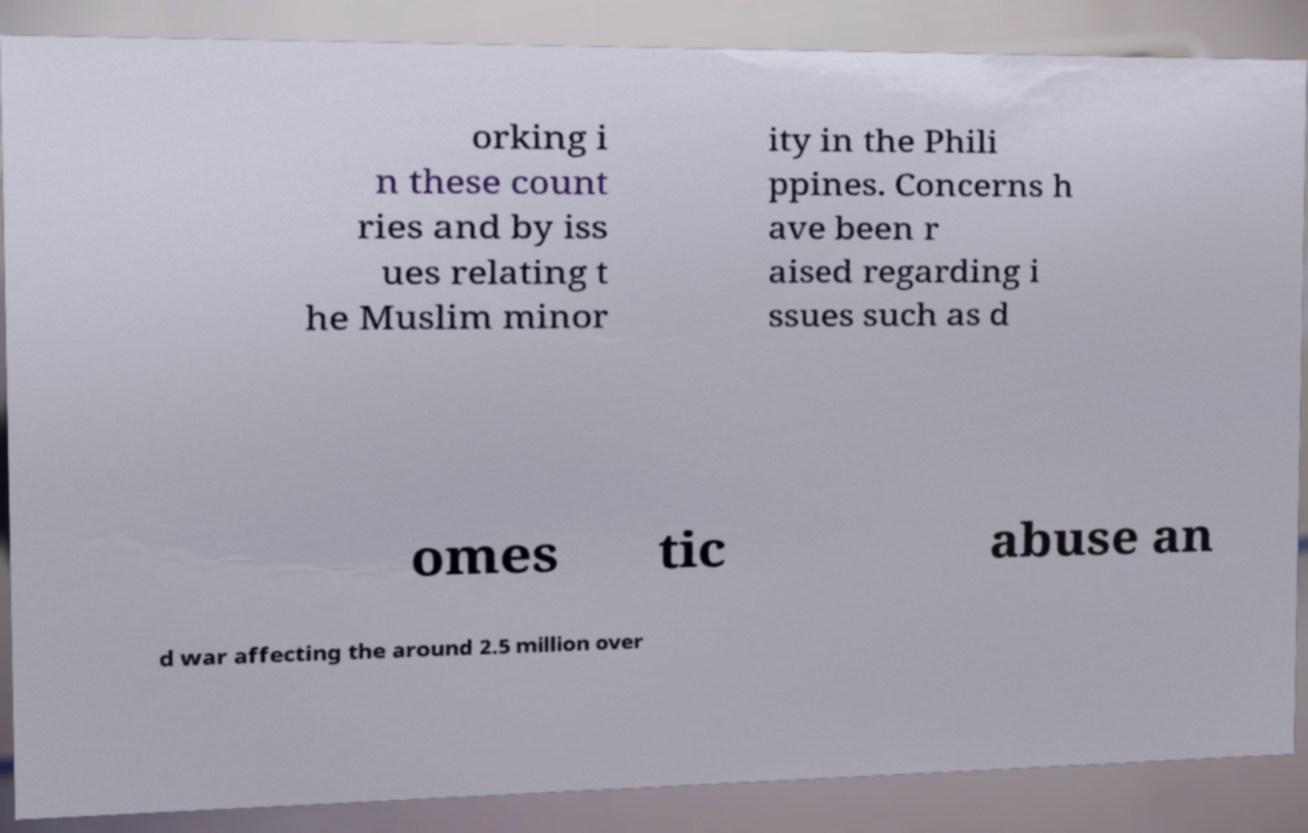Please read and relay the text visible in this image. What does it say? orking i n these count ries and by iss ues relating t he Muslim minor ity in the Phili ppines. Concerns h ave been r aised regarding i ssues such as d omes tic abuse an d war affecting the around 2.5 million over 